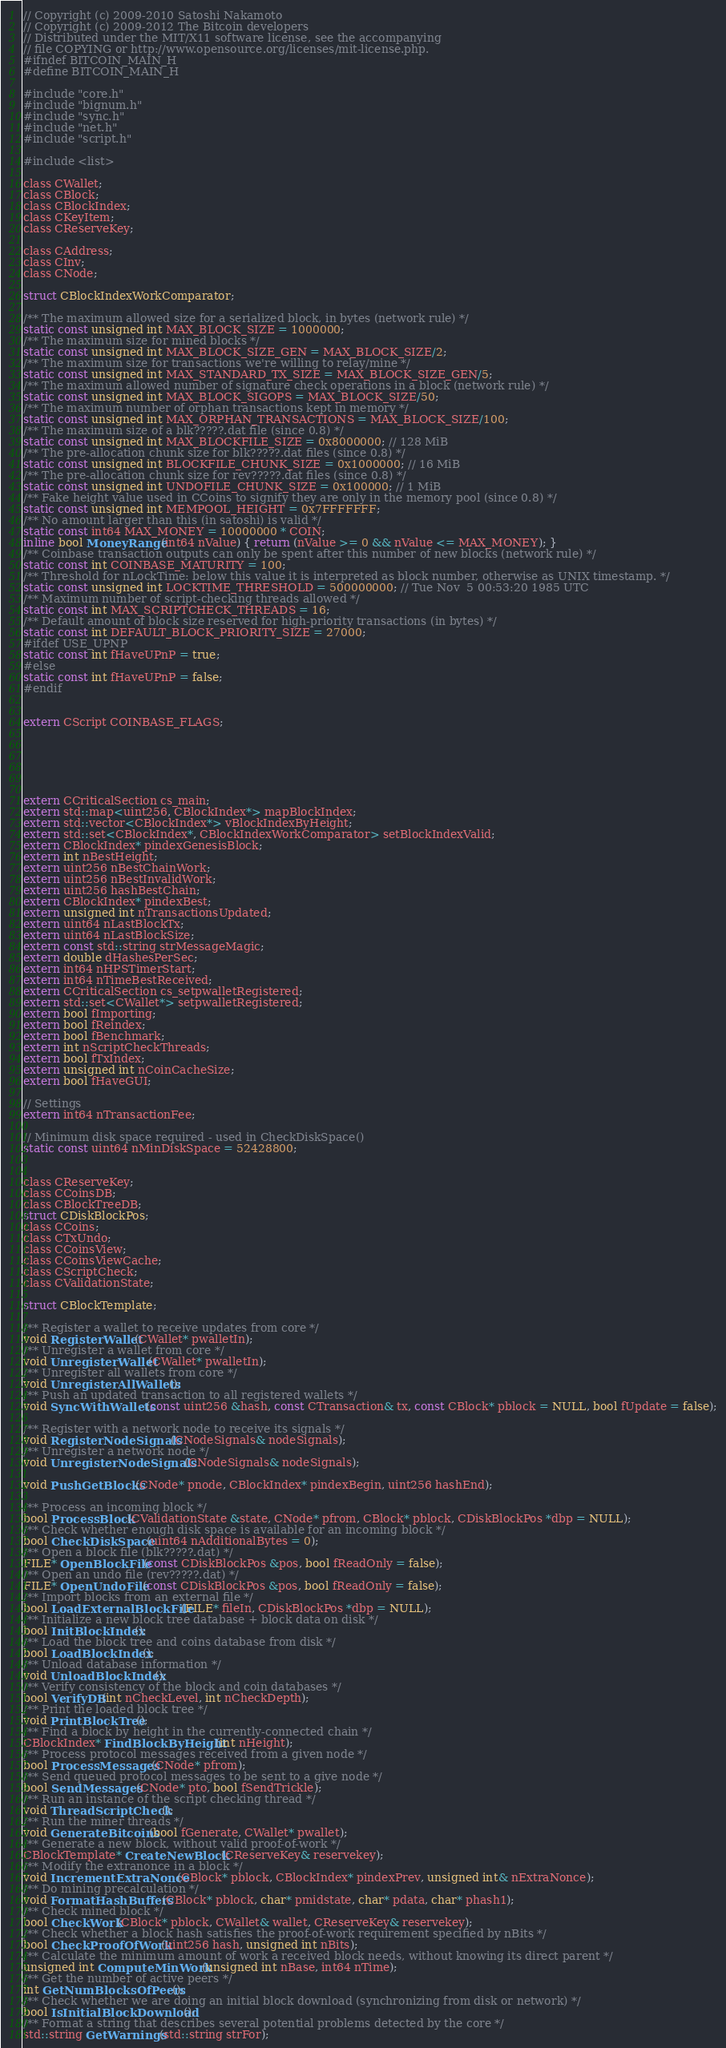Convert code to text. <code><loc_0><loc_0><loc_500><loc_500><_C_>// Copyright (c) 2009-2010 Satoshi Nakamoto
// Copyright (c) 2009-2012 The Bitcoin developers
// Distributed under the MIT/X11 software license, see the accompanying
// file COPYING or http://www.opensource.org/licenses/mit-license.php.
#ifndef BITCOIN_MAIN_H
#define BITCOIN_MAIN_H

#include "core.h"
#include "bignum.h"
#include "sync.h"
#include "net.h"
#include "script.h"

#include <list>

class CWallet;
class CBlock;
class CBlockIndex;
class CKeyItem;
class CReserveKey;

class CAddress;
class CInv;
class CNode;

struct CBlockIndexWorkComparator;

/** The maximum allowed size for a serialized block, in bytes (network rule) */
static const unsigned int MAX_BLOCK_SIZE = 1000000;
/** The maximum size for mined blocks */
static const unsigned int MAX_BLOCK_SIZE_GEN = MAX_BLOCK_SIZE/2;
/** The maximum size for transactions we're willing to relay/mine */
static const unsigned int MAX_STANDARD_TX_SIZE = MAX_BLOCK_SIZE_GEN/5;
/** The maximum allowed number of signature check operations in a block (network rule) */
static const unsigned int MAX_BLOCK_SIGOPS = MAX_BLOCK_SIZE/50;
/** The maximum number of orphan transactions kept in memory */
static const unsigned int MAX_ORPHAN_TRANSACTIONS = MAX_BLOCK_SIZE/100;
/** The maximum size of a blk?????.dat file (since 0.8) */
static const unsigned int MAX_BLOCKFILE_SIZE = 0x8000000; // 128 MiB
/** The pre-allocation chunk size for blk?????.dat files (since 0.8) */
static const unsigned int BLOCKFILE_CHUNK_SIZE = 0x1000000; // 16 MiB
/** The pre-allocation chunk size for rev?????.dat files (since 0.8) */
static const unsigned int UNDOFILE_CHUNK_SIZE = 0x100000; // 1 MiB
/** Fake height value used in CCoins to signify they are only in the memory pool (since 0.8) */
static const unsigned int MEMPOOL_HEIGHT = 0x7FFFFFFF;
/** No amount larger than this (in satoshi) is valid */
static const int64 MAX_MONEY = 10000000 * COIN;
inline bool MoneyRange(int64 nValue) { return (nValue >= 0 && nValue <= MAX_MONEY); }
/** Coinbase transaction outputs can only be spent after this number of new blocks (network rule) */
static const int COINBASE_MATURITY = 100;
/** Threshold for nLockTime: below this value it is interpreted as block number, otherwise as UNIX timestamp. */
static const unsigned int LOCKTIME_THRESHOLD = 500000000; // Tue Nov  5 00:53:20 1985 UTC
/** Maximum number of script-checking threads allowed */
static const int MAX_SCRIPTCHECK_THREADS = 16;
/** Default amount of block size reserved for high-priority transactions (in bytes) */
static const int DEFAULT_BLOCK_PRIORITY_SIZE = 27000;
#ifdef USE_UPNP
static const int fHaveUPnP = true;
#else
static const int fHaveUPnP = false;
#endif


extern CScript COINBASE_FLAGS;






extern CCriticalSection cs_main;
extern std::map<uint256, CBlockIndex*> mapBlockIndex;
extern std::vector<CBlockIndex*> vBlockIndexByHeight;
extern std::set<CBlockIndex*, CBlockIndexWorkComparator> setBlockIndexValid;
extern CBlockIndex* pindexGenesisBlock;
extern int nBestHeight;
extern uint256 nBestChainWork;
extern uint256 nBestInvalidWork;
extern uint256 hashBestChain;
extern CBlockIndex* pindexBest;
extern unsigned int nTransactionsUpdated;
extern uint64 nLastBlockTx;
extern uint64 nLastBlockSize;
extern const std::string strMessageMagic;
extern double dHashesPerSec;
extern int64 nHPSTimerStart;
extern int64 nTimeBestReceived;
extern CCriticalSection cs_setpwalletRegistered;
extern std::set<CWallet*> setpwalletRegistered;
extern bool fImporting;
extern bool fReindex;
extern bool fBenchmark;
extern int nScriptCheckThreads;
extern bool fTxIndex;
extern unsigned int nCoinCacheSize;
extern bool fHaveGUI;

// Settings
extern int64 nTransactionFee;

// Minimum disk space required - used in CheckDiskSpace()
static const uint64 nMinDiskSpace = 52428800;


class CReserveKey;
class CCoinsDB;
class CBlockTreeDB;
struct CDiskBlockPos;
class CCoins;
class CTxUndo;
class CCoinsView;
class CCoinsViewCache;
class CScriptCheck;
class CValidationState;

struct CBlockTemplate;

/** Register a wallet to receive updates from core */
void RegisterWallet(CWallet* pwalletIn);
/** Unregister a wallet from core */
void UnregisterWallet(CWallet* pwalletIn);
/** Unregister all wallets from core */
void UnregisterAllWallets();
/** Push an updated transaction to all registered wallets */
void SyncWithWallets(const uint256 &hash, const CTransaction& tx, const CBlock* pblock = NULL, bool fUpdate = false);

/** Register with a network node to receive its signals */
void RegisterNodeSignals(CNodeSignals& nodeSignals);
/** Unregister a network node */
void UnregisterNodeSignals(CNodeSignals& nodeSignals);

void PushGetBlocks(CNode* pnode, CBlockIndex* pindexBegin, uint256 hashEnd);

/** Process an incoming block */
bool ProcessBlock(CValidationState &state, CNode* pfrom, CBlock* pblock, CDiskBlockPos *dbp = NULL);
/** Check whether enough disk space is available for an incoming block */
bool CheckDiskSpace(uint64 nAdditionalBytes = 0);
/** Open a block file (blk?????.dat) */
FILE* OpenBlockFile(const CDiskBlockPos &pos, bool fReadOnly = false);
/** Open an undo file (rev?????.dat) */
FILE* OpenUndoFile(const CDiskBlockPos &pos, bool fReadOnly = false);
/** Import blocks from an external file */
bool LoadExternalBlockFile(FILE* fileIn, CDiskBlockPos *dbp = NULL);
/** Initialize a new block tree database + block data on disk */
bool InitBlockIndex();
/** Load the block tree and coins database from disk */
bool LoadBlockIndex();
/** Unload database information */
void UnloadBlockIndex();
/** Verify consistency of the block and coin databases */
bool VerifyDB(int nCheckLevel, int nCheckDepth);
/** Print the loaded block tree */
void PrintBlockTree();
/** Find a block by height in the currently-connected chain */
CBlockIndex* FindBlockByHeight(int nHeight);
/** Process protocol messages received from a given node */
bool ProcessMessages(CNode* pfrom);
/** Send queued protocol messages to be sent to a give node */
bool SendMessages(CNode* pto, bool fSendTrickle);
/** Run an instance of the script checking thread */
void ThreadScriptCheck();
/** Run the miner threads */
void GenerateBitcoins(bool fGenerate, CWallet* pwallet);
/** Generate a new block, without valid proof-of-work */
CBlockTemplate* CreateNewBlock(CReserveKey& reservekey);
/** Modify the extranonce in a block */
void IncrementExtraNonce(CBlock* pblock, CBlockIndex* pindexPrev, unsigned int& nExtraNonce);
/** Do mining precalculation */
void FormatHashBuffers(CBlock* pblock, char* pmidstate, char* pdata, char* phash1);
/** Check mined block */
bool CheckWork(CBlock* pblock, CWallet& wallet, CReserveKey& reservekey);
/** Check whether a block hash satisfies the proof-of-work requirement specified by nBits */
bool CheckProofOfWork(uint256 hash, unsigned int nBits);
/** Calculate the minimum amount of work a received block needs, without knowing its direct parent */
unsigned int ComputeMinWork(unsigned int nBase, int64 nTime);
/** Get the number of active peers */
int GetNumBlocksOfPeers();
/** Check whether we are doing an initial block download (synchronizing from disk or network) */
bool IsInitialBlockDownload();
/** Format a string that describes several potential problems detected by the core */
std::string GetWarnings(std::string strFor);</code> 